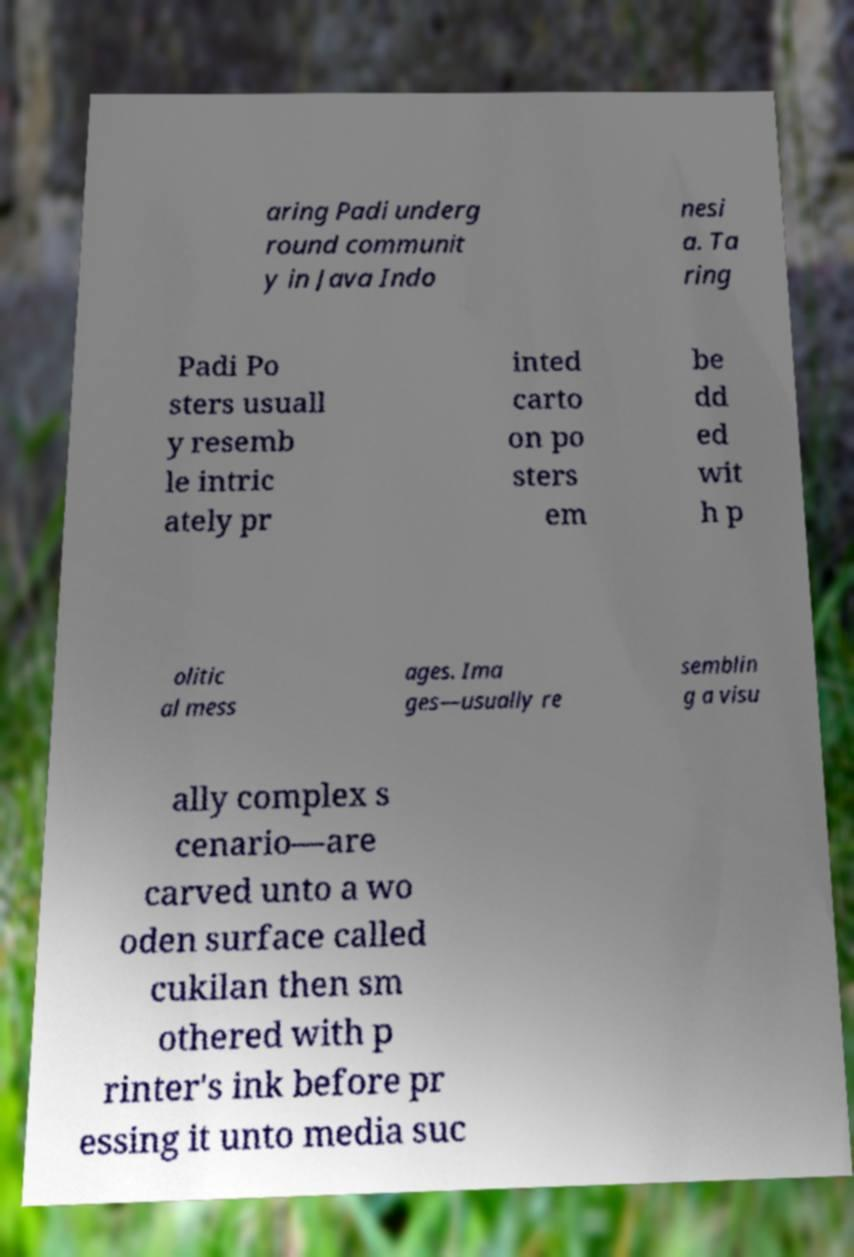Can you read and provide the text displayed in the image?This photo seems to have some interesting text. Can you extract and type it out for me? aring Padi underg round communit y in Java Indo nesi a. Ta ring Padi Po sters usuall y resemb le intric ately pr inted carto on po sters em be dd ed wit h p olitic al mess ages. Ima ges—usually re semblin g a visu ally complex s cenario—are carved unto a wo oden surface called cukilan then sm othered with p rinter's ink before pr essing it unto media suc 